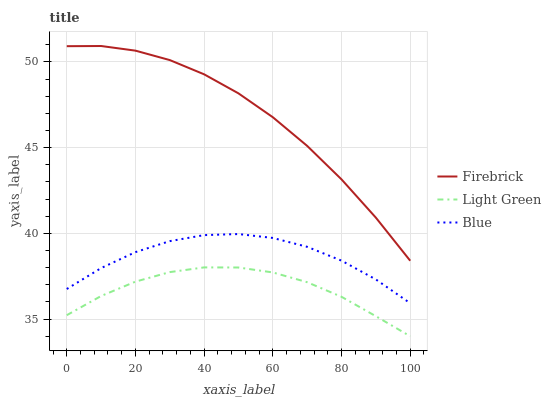Does Light Green have the minimum area under the curve?
Answer yes or no. Yes. Does Firebrick have the maximum area under the curve?
Answer yes or no. Yes. Does Firebrick have the minimum area under the curve?
Answer yes or no. No. Does Light Green have the maximum area under the curve?
Answer yes or no. No. Is Light Green the smoothest?
Answer yes or no. Yes. Is Blue the roughest?
Answer yes or no. Yes. Is Firebrick the smoothest?
Answer yes or no. No. Is Firebrick the roughest?
Answer yes or no. No. Does Firebrick have the lowest value?
Answer yes or no. No. Does Light Green have the highest value?
Answer yes or no. No. Is Blue less than Firebrick?
Answer yes or no. Yes. Is Firebrick greater than Blue?
Answer yes or no. Yes. Does Blue intersect Firebrick?
Answer yes or no. No. 